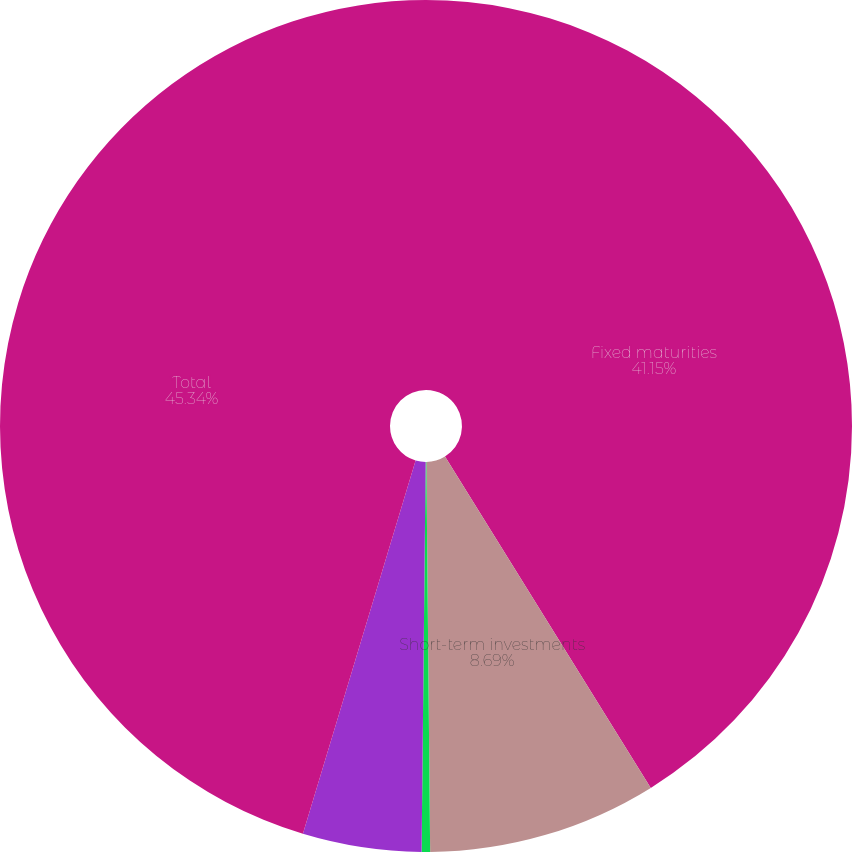Convert chart to OTSL. <chart><loc_0><loc_0><loc_500><loc_500><pie_chart><fcel>Fixed maturities<fcel>Short-term investments<fcel>Cash<fcel>Less Derivative collateral<fcel>Total<nl><fcel>41.15%<fcel>8.69%<fcel>0.32%<fcel>4.5%<fcel>45.33%<nl></chart> 